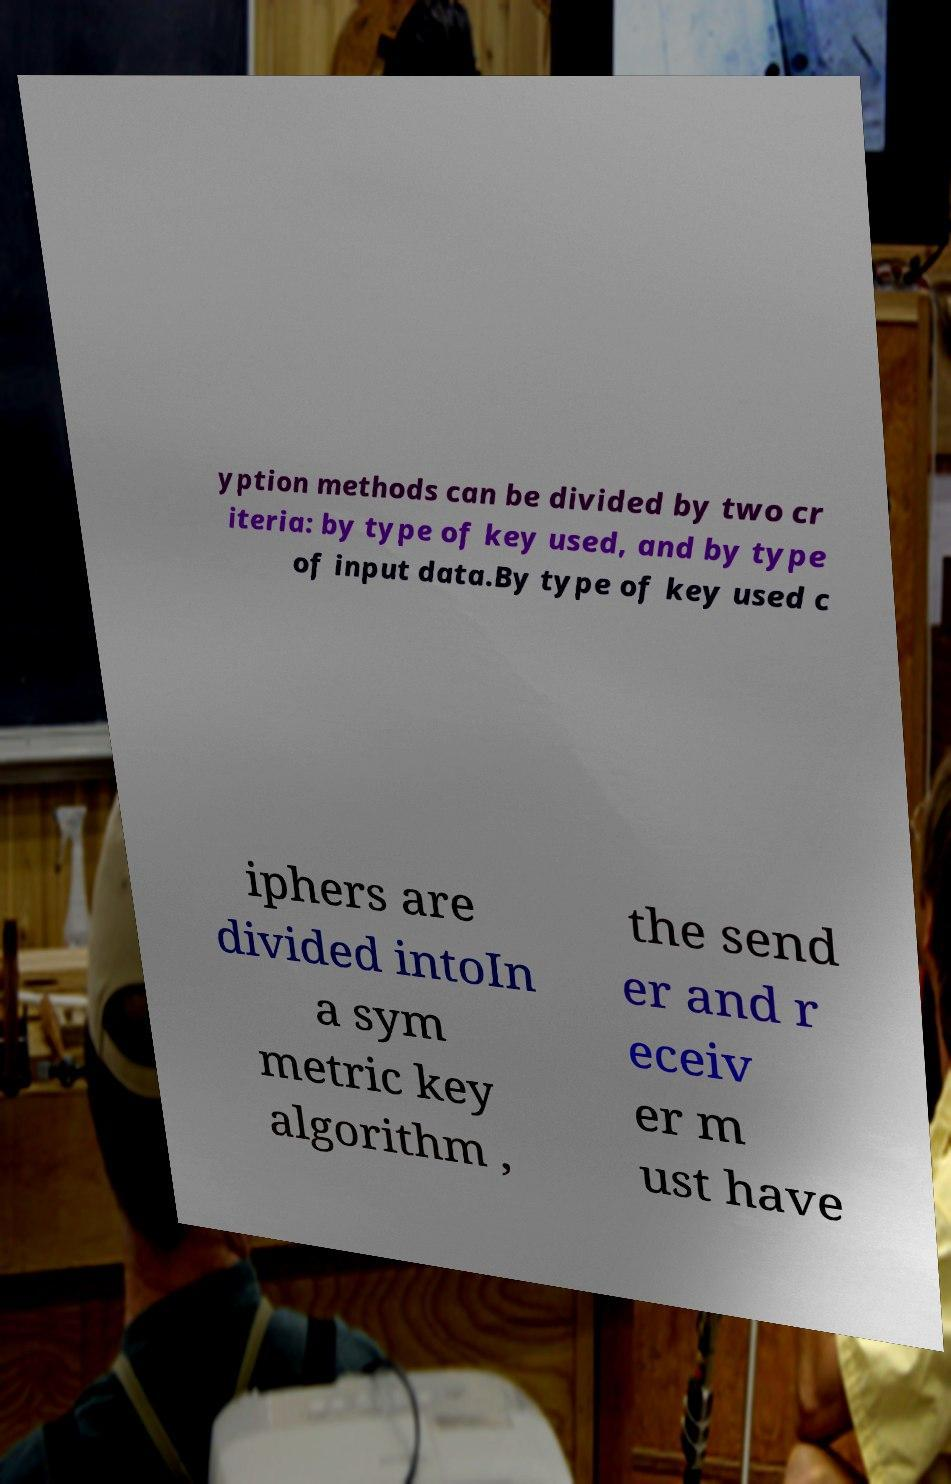For documentation purposes, I need the text within this image transcribed. Could you provide that? yption methods can be divided by two cr iteria: by type of key used, and by type of input data.By type of key used c iphers are divided intoIn a sym metric key algorithm , the send er and r eceiv er m ust have 